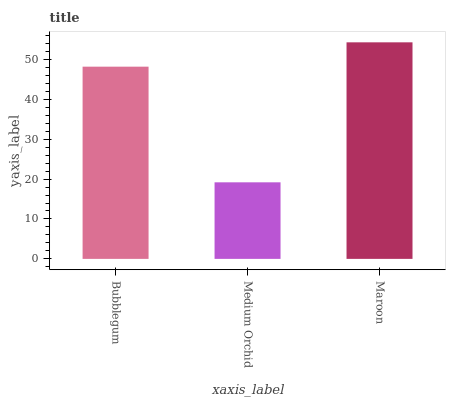Is Medium Orchid the minimum?
Answer yes or no. Yes. Is Maroon the maximum?
Answer yes or no. Yes. Is Maroon the minimum?
Answer yes or no. No. Is Medium Orchid the maximum?
Answer yes or no. No. Is Maroon greater than Medium Orchid?
Answer yes or no. Yes. Is Medium Orchid less than Maroon?
Answer yes or no. Yes. Is Medium Orchid greater than Maroon?
Answer yes or no. No. Is Maroon less than Medium Orchid?
Answer yes or no. No. Is Bubblegum the high median?
Answer yes or no. Yes. Is Bubblegum the low median?
Answer yes or no. Yes. Is Medium Orchid the high median?
Answer yes or no. No. Is Maroon the low median?
Answer yes or no. No. 